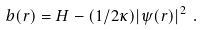<formula> <loc_0><loc_0><loc_500><loc_500>b ( { r } ) = H - ( 1 / 2 \kappa ) | \psi ( { r } ) | ^ { 2 } \ .</formula> 